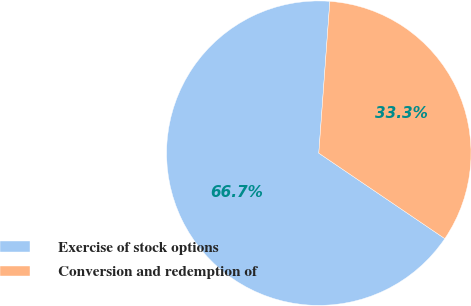Convert chart. <chart><loc_0><loc_0><loc_500><loc_500><pie_chart><fcel>Exercise of stock options<fcel>Conversion and redemption of<nl><fcel>66.67%<fcel>33.33%<nl></chart> 